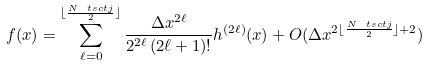<formula> <loc_0><loc_0><loc_500><loc_500>f ( x ) = \sum _ { \ell = 0 } ^ { \lfloor \frac { N _ { \ } t s c { t j } } { 2 } \rfloor } \frac { \Delta x ^ { 2 \ell } } { 2 ^ { 2 \ell } \, ( 2 \ell + 1 ) ! } h ^ { ( 2 \ell ) } ( x ) + O ( \Delta x ^ { 2 \lfloor \frac { N _ { \ } t s c { t j } } { 2 } \rfloor + 2 } )</formula> 